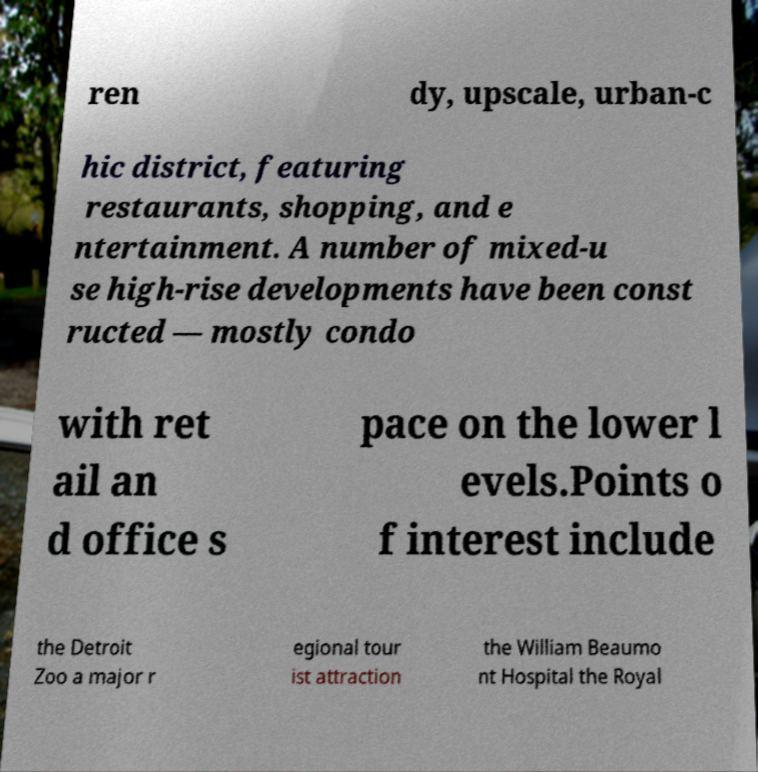Can you read and provide the text displayed in the image?This photo seems to have some interesting text. Can you extract and type it out for me? ren dy, upscale, urban-c hic district, featuring restaurants, shopping, and e ntertainment. A number of mixed-u se high-rise developments have been const ructed — mostly condo with ret ail an d office s pace on the lower l evels.Points o f interest include the Detroit Zoo a major r egional tour ist attraction the William Beaumo nt Hospital the Royal 